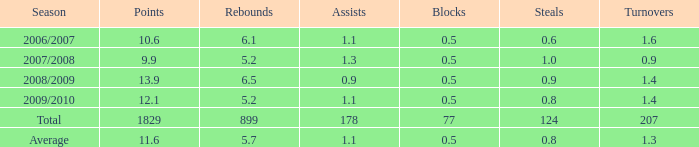9 steals and less than None. 